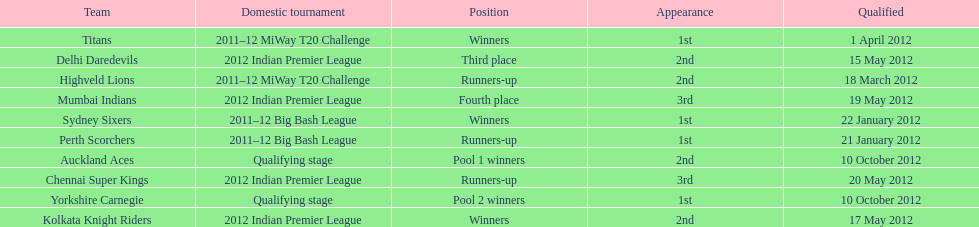Which team succeeded the titans in the miway t20 challenge? Highveld Lions. I'm looking to parse the entire table for insights. Could you assist me with that? {'header': ['Team', 'Domestic tournament', 'Position', 'Appearance', 'Qualified'], 'rows': [['Titans', '2011–12 MiWay T20 Challenge', 'Winners', '1st', '1 April 2012'], ['Delhi Daredevils', '2012 Indian Premier League', 'Third place', '2nd', '15 May 2012'], ['Highveld Lions', '2011–12 MiWay T20 Challenge', 'Runners-up', '2nd', '18 March 2012'], ['Mumbai Indians', '2012 Indian Premier League', 'Fourth place', '3rd', '19 May 2012'], ['Sydney Sixers', '2011–12 Big Bash League', 'Winners', '1st', '22 January 2012'], ['Perth Scorchers', '2011–12 Big Bash League', 'Runners-up', '1st', '21 January 2012'], ['Auckland Aces', 'Qualifying stage', 'Pool 1 winners', '2nd', '10 October 2012'], ['Chennai Super Kings', '2012 Indian Premier League', 'Runners-up', '3rd', '20 May 2012'], ['Yorkshire Carnegie', 'Qualifying stage', 'Pool 2 winners', '1st', '10 October 2012'], ['Kolkata Knight Riders', '2012 Indian Premier League', 'Winners', '2nd', '17 May 2012']]} 